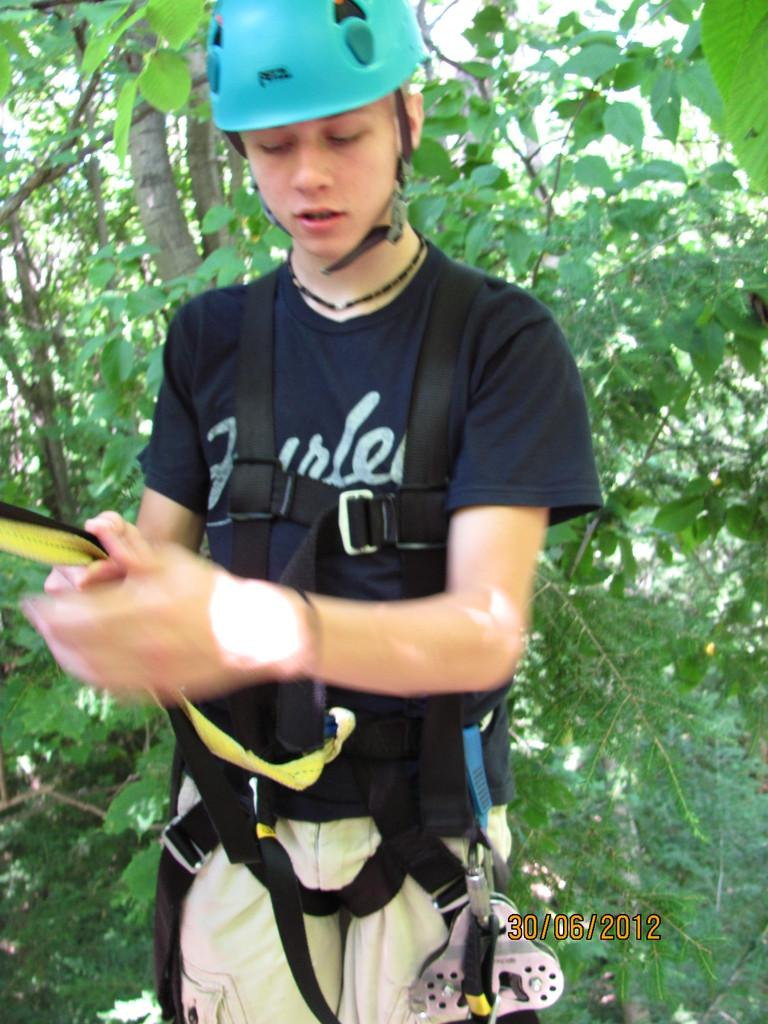Who is present in the image? There is a person in the image. What is the person wearing on their head? The person is wearing a helmet. What type of clothing is the person wearing around their waist? The person is wearing belts. What can be seen in the distance in the image? There are trees in the background of the image. What is visible in the image that might convey information or a message? There is text visible in the image. Can you see the person's friend in the image? There is no mention of a friend in the image. --- Facts: 1. There is a person in the image. 2. The person is holding a book. 3. The book has a blue cover. 4. The person is sitting on a chair. 5. There is a table next to the person. Absurd Topics: elephant, ocean, bicycle Conversation: Who is present in the image? There is a person in the image. What is the person holding in the image? The person is holding a book. What can be said about the book's cover? The book has a blue cover. What is the person's seating position in the image? The person is sitting on a chair. What is located next to the person in the image? There is a table next to the person. Reasoning: Let's think step by step in order to produce the conversation. We start by identifying the main subject in the image, which is the person. Then, we describe what the person is doing or holding, which in this case is a book. Next, we provide details about the book, such as its blue cover. After that, we mention the person's seating position, which is sitting on a chair. Finally, we describe the object located next to the person, which is a table. Absurd Question/Answer: Can you see an elephant in the image? There is no mention of an elephant in the image. 